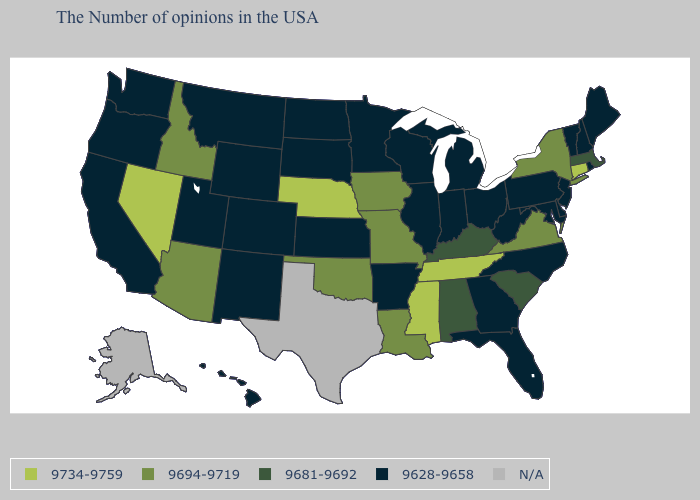What is the highest value in the USA?
Quick response, please. 9734-9759. Name the states that have a value in the range 9734-9759?
Short answer required. Connecticut, Tennessee, Mississippi, Nebraska, Nevada. What is the value of California?
Short answer required. 9628-9658. Is the legend a continuous bar?
Answer briefly. No. What is the value of Minnesota?
Quick response, please. 9628-9658. What is the lowest value in the USA?
Short answer required. 9628-9658. What is the value of North Dakota?
Concise answer only. 9628-9658. Name the states that have a value in the range 9694-9719?
Be succinct. New York, Virginia, Louisiana, Missouri, Iowa, Oklahoma, Arizona, Idaho. Name the states that have a value in the range 9734-9759?
Give a very brief answer. Connecticut, Tennessee, Mississippi, Nebraska, Nevada. What is the value of Texas?
Give a very brief answer. N/A. How many symbols are there in the legend?
Write a very short answer. 5. What is the value of Iowa?
Keep it brief. 9694-9719. What is the highest value in the West ?
Be succinct. 9734-9759. Among the states that border Montana , which have the highest value?
Keep it brief. Idaho. Among the states that border Kansas , which have the lowest value?
Give a very brief answer. Colorado. 